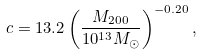Convert formula to latex. <formula><loc_0><loc_0><loc_500><loc_500>c = 1 3 . 2 \left ( \frac { M _ { 2 0 0 } } { 1 0 ^ { 1 3 } M _ { \odot } } \right ) ^ { - 0 . 2 0 } ,</formula> 